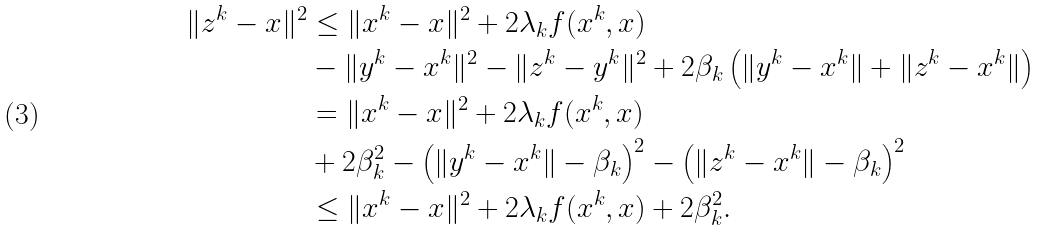Convert formula to latex. <formula><loc_0><loc_0><loc_500><loc_500>\| z ^ { k } - x \| ^ { 2 } & \leq \| x ^ { k } - x \| ^ { 2 } + 2 \lambda _ { k } f ( x ^ { k } , x ) \\ & - \| y ^ { k } - x ^ { k } \| ^ { 2 } - \| z ^ { k } - y ^ { k } \| ^ { 2 } + 2 \beta _ { k } \left ( \| y ^ { k } - x ^ { k } \| + \| z ^ { k } - x ^ { k } \| \right ) \\ & = \| x ^ { k } - x \| ^ { 2 } + 2 \lambda _ { k } f ( x ^ { k } , x ) \\ & + 2 \beta _ { k } ^ { 2 } - \left ( \| y ^ { k } - x ^ { k } \| - \beta _ { k } \right ) ^ { 2 } - \left ( \| z ^ { k } - x ^ { k } \| - \beta _ { k } \right ) ^ { 2 } \\ & \leq \| x ^ { k } - x \| ^ { 2 } + 2 \lambda _ { k } f ( x ^ { k } , x ) + 2 \beta _ { k } ^ { 2 } .</formula> 